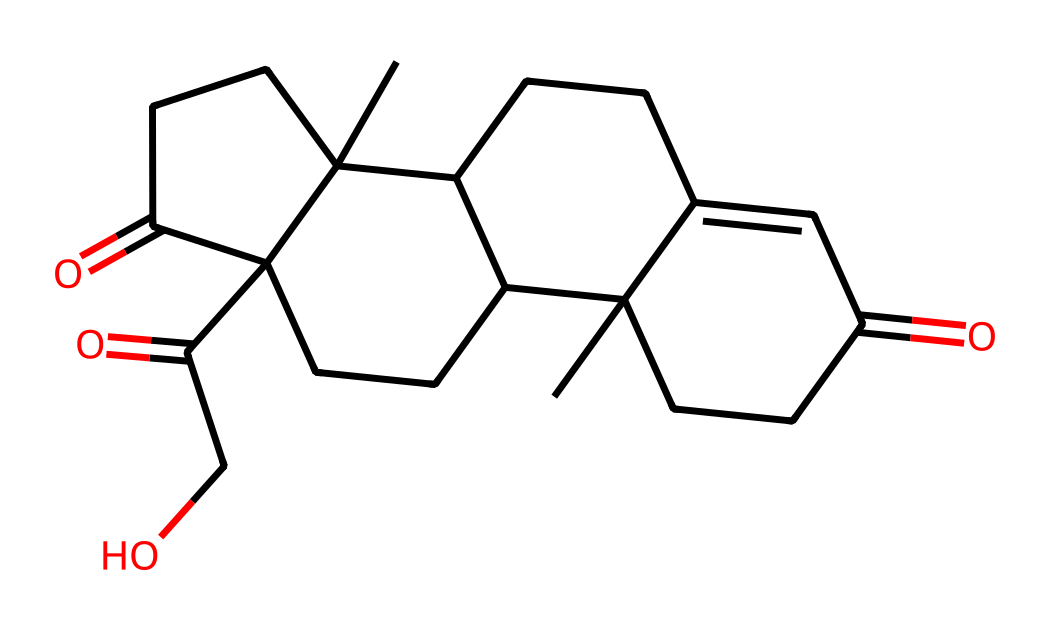how many carbon atoms are in cortisol? To determine the number of carbon atoms, I count the carbon symbols (C) in the SMILES representation. There are 21 carbon atoms present.
Answer: 21 how many oxygen atoms are in cortisol? By counting the oxygen symbols (O) in the SMILES representation, I find there are 5 oxygen atoms present in the structure.
Answer: 5 what is the molecular formula of cortisol? The molecular formula can be derived by counting each type of atom from the SMILES representation - 21 carbon, 30 hydrogen, and 5 oxygen gives C21H30O5.
Answer: C21H30O5 what type of functional groups does cortisol contain? Looking at the chemical structure, cortisol contains ketone functional groups (C=O) and alcohol (OH) groups, which are common in steroids.
Answer: ketone and alcohol what type of hormone is cortisol classified as? Cortisol is classified as a glucocorticoid, which is a category of steroid hormones. This can be inferred from its structure, which shares features with corticosteroids.
Answer: glucocorticoid what is the primary biological function of cortisol? The primary biological function of cortisol is to regulate metabolism and the body's response to stress, as well as to modulate immune responses.
Answer: regulate metabolism and stress response how does the structure of cortisol relate to its function as a stress hormone? The structure of cortisol, particularly the presence of hydroxyl and carbonyl groups, allows it to interact effectively with glucocorticoid receptors, mediating stress responses and anti-inflammatory effects.
Answer: receptor interaction and mediation of responses 